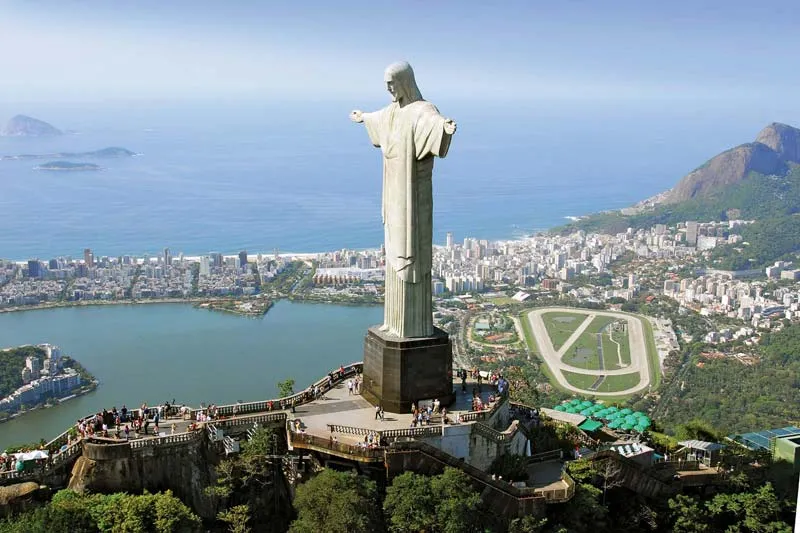Why is this statue considered a symbol of peace? Christ the Redeemer is considered a symbol of peace due to its open arms gesture, which is seen as embracing all who visit or view it. This posture represents an invitation to peace and openness among people. Additionally, its status as a religious figure of Jesus Christ contributes to its image as a beacon of hope and reconciliation, further embodying peaceful and humanitarian values. 